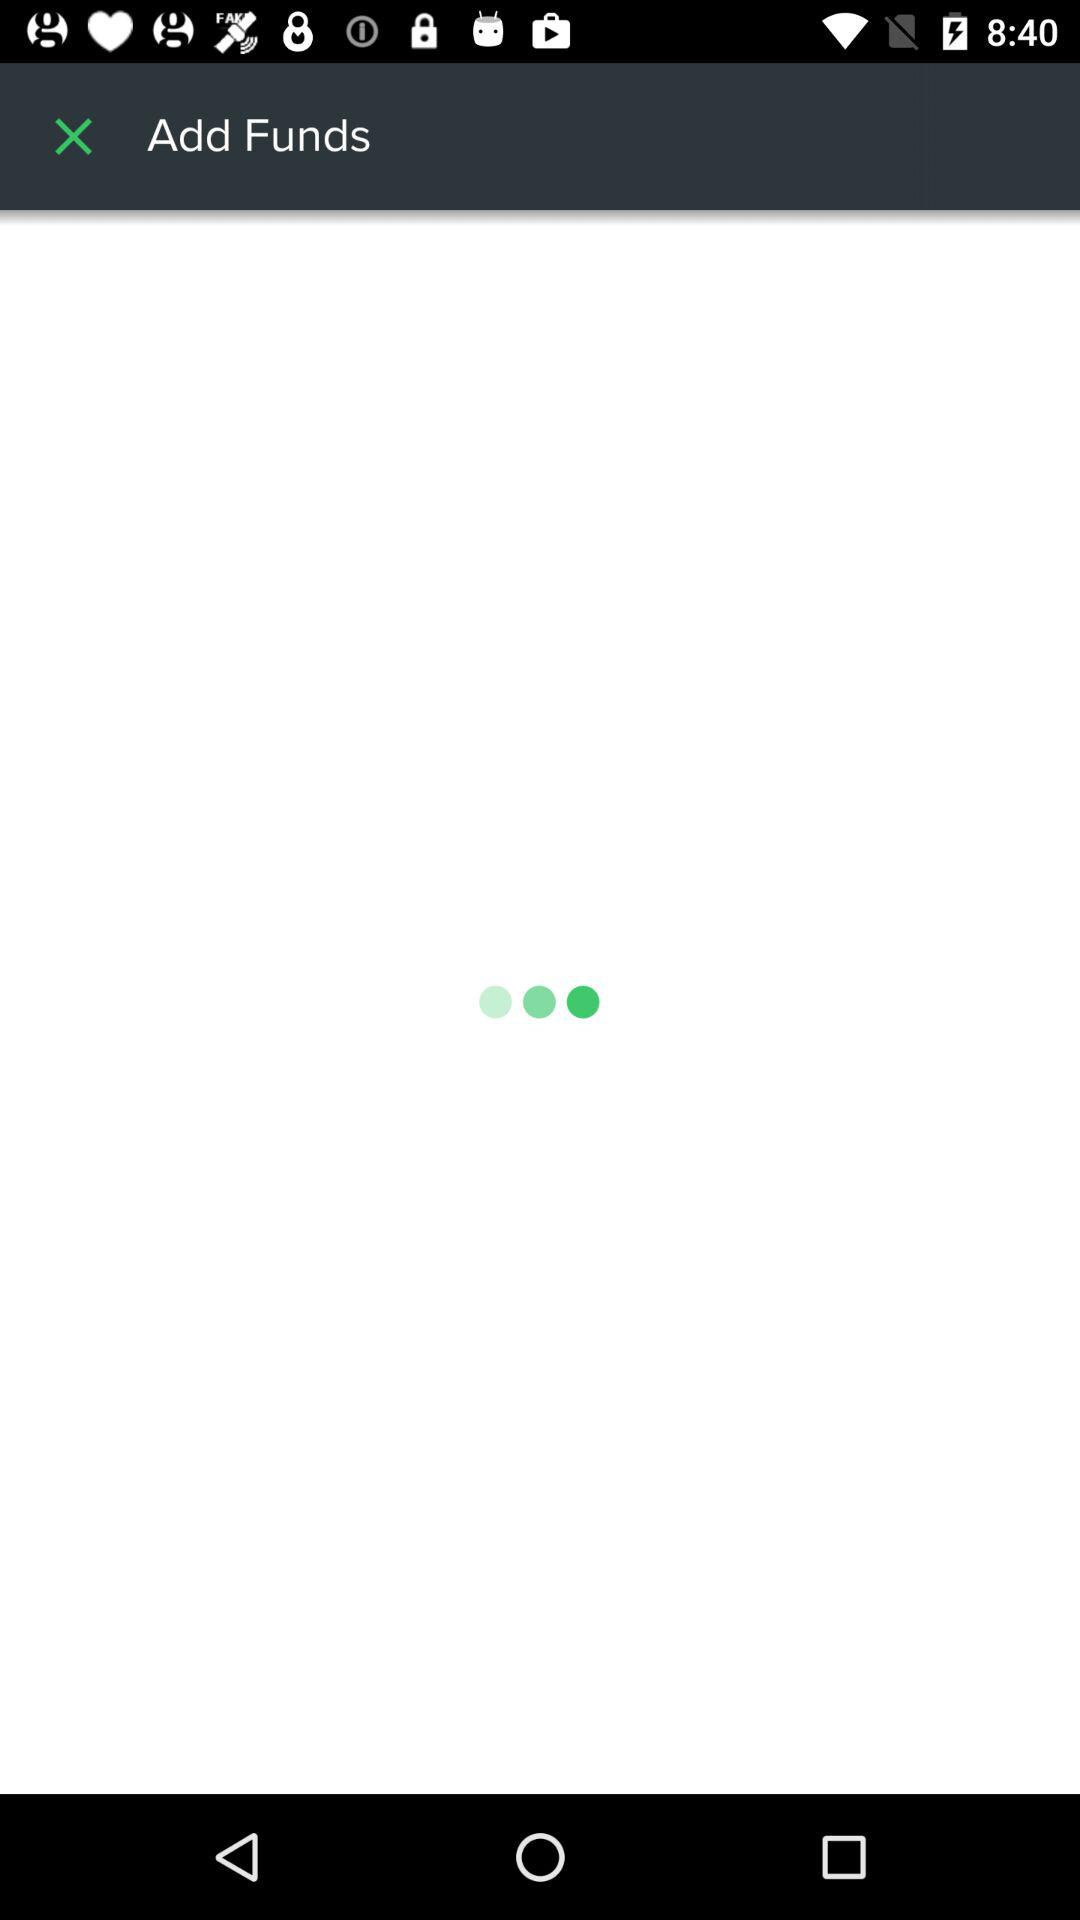What is the status of the "Keep me logged in"? The status is on. 